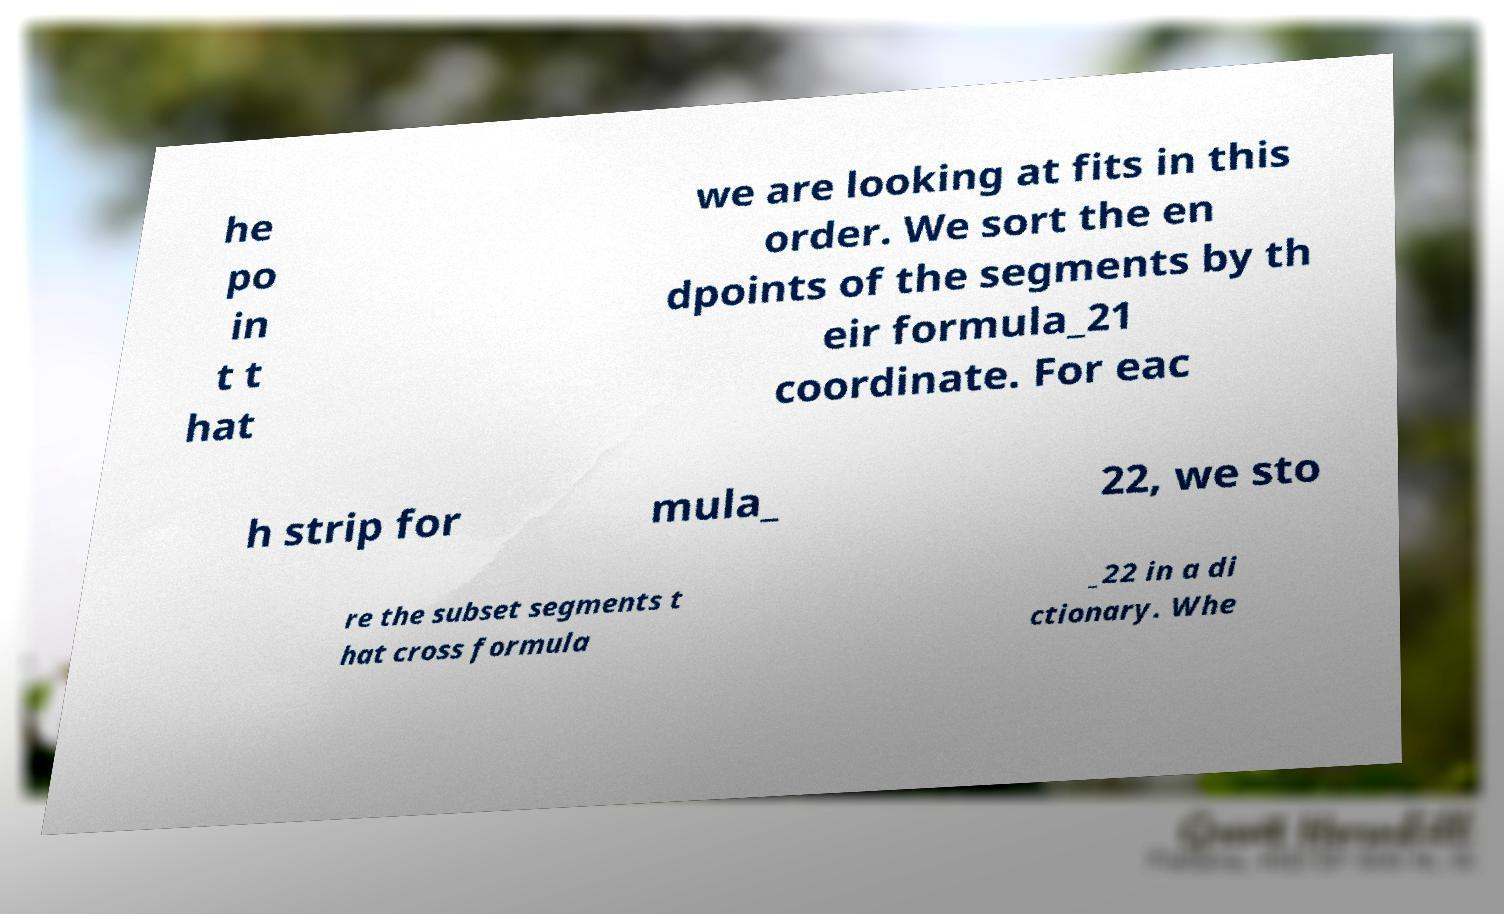Please identify and transcribe the text found in this image. he po in t t hat we are looking at fits in this order. We sort the en dpoints of the segments by th eir formula_21 coordinate. For eac h strip for mula_ 22, we sto re the subset segments t hat cross formula _22 in a di ctionary. Whe 